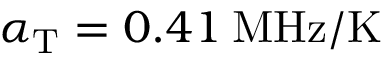<formula> <loc_0><loc_0><loc_500><loc_500>\alpha _ { T } = 0 . 4 1 \, M H z / K</formula> 